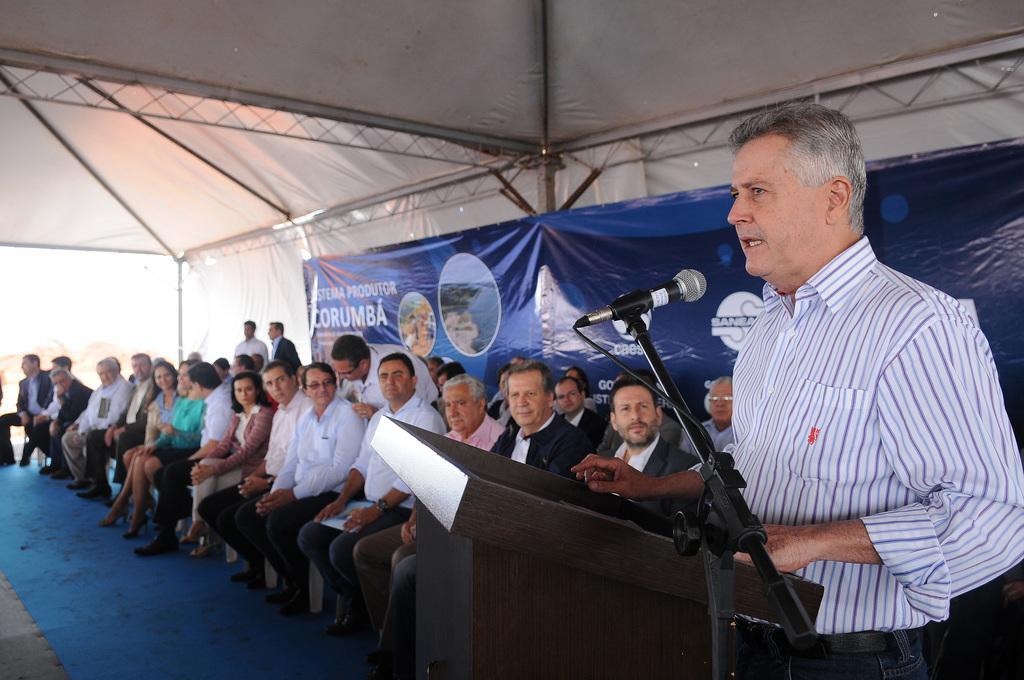How would you summarize this image in a sentence or two? In this picture we can see some people sitting on chairs, a man on the right side is standing and speaking something, we can see a podium and a microphone here, there is a banner in the background. 